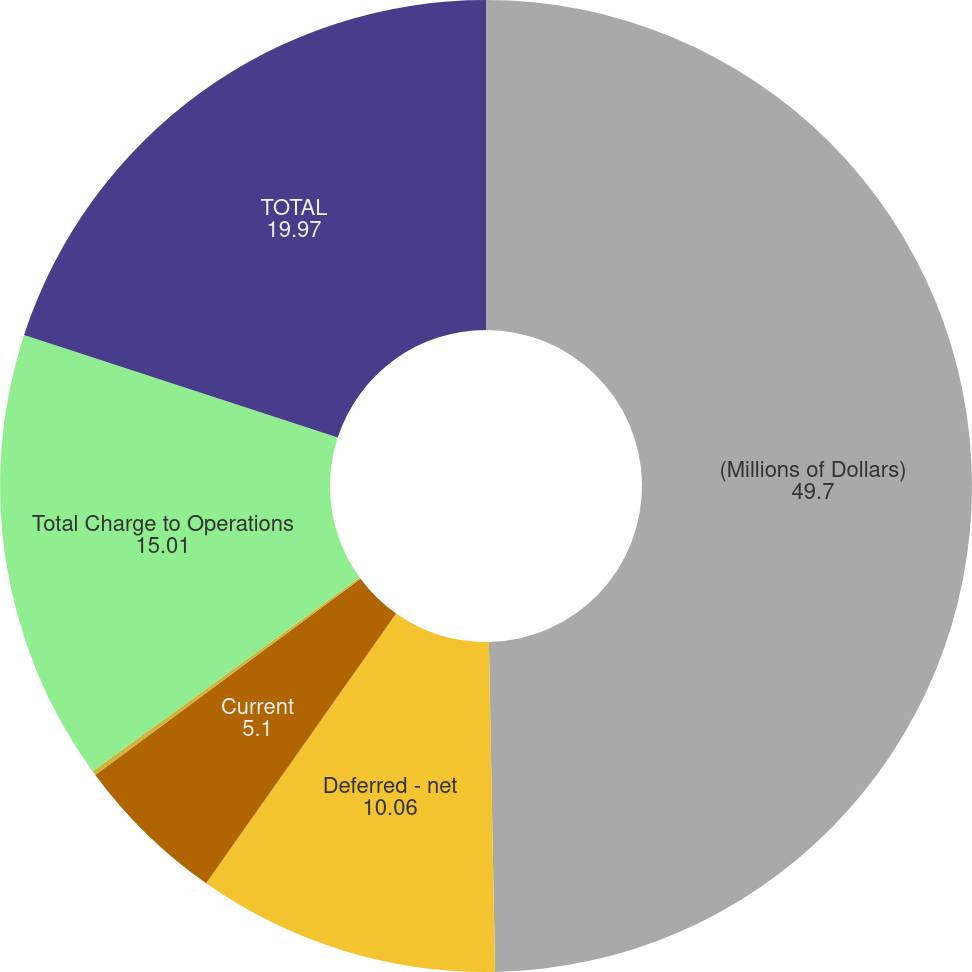Convert chart to OTSL. <chart><loc_0><loc_0><loc_500><loc_500><pie_chart><fcel>(Millions of Dollars)<fcel>Deferred - net<fcel>Current<fcel>Amortization of investment tax<fcel>Total Charge to Operations<fcel>TOTAL<nl><fcel>49.7%<fcel>10.06%<fcel>5.1%<fcel>0.15%<fcel>15.01%<fcel>19.97%<nl></chart> 